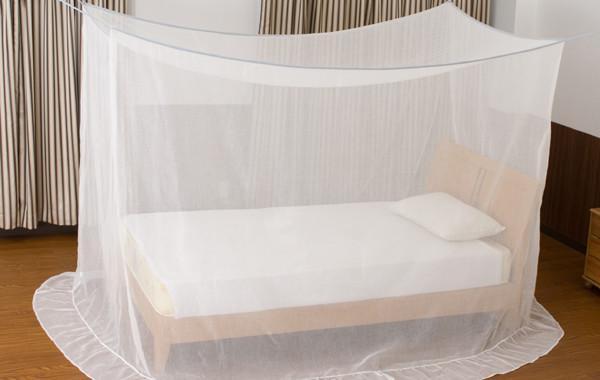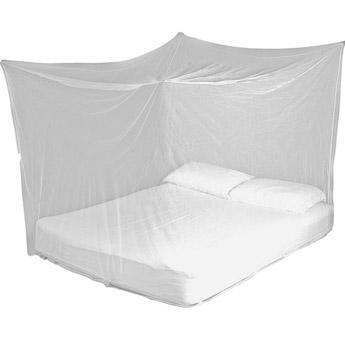The first image is the image on the left, the second image is the image on the right. For the images displayed, is the sentence "The right net/drape has a cone on the top." factually correct? Answer yes or no. No. The first image is the image on the left, the second image is the image on the right. Evaluate the accuracy of this statement regarding the images: "There are  two canopies that white beds and at least one is square.". Is it true? Answer yes or no. Yes. 